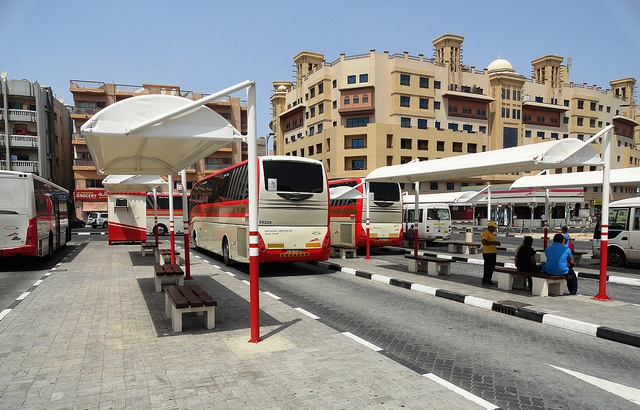Describe the objects in this image and their specific colors. I can see bus in darkgray, black, and gray tones, bus in darkgray, black, gray, and maroon tones, bus in darkgray, black, gray, and maroon tones, bus in darkgray, black, gray, and lightgray tones, and bus in darkgray, black, gray, and lightgray tones in this image. 